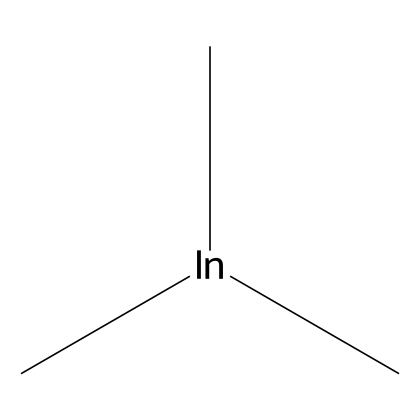What is the central metal atom in trimethylindium? The SMILES representation indicates the presence of 'In', which stands for indium, as the central metal atom in the compound.
Answer: indium How many carbon atoms are present in trimethylindium? The SMILES structure shows three 'C' atoms, meaning there are three carbon atoms in the compound.
Answer: three What type of bonding characterizes the carbon-indium structure in trimethylindium? The presence of carbon bonded to indium suggests covalent bonding, as organometallic compounds typically exhibit covalent connections between metals and organic groups.
Answer: covalent What is the formula for trimethylindium? By interpreting the SMILES code, we can count components: there are three methyl groups (each represented by 'C') and one indium ('In'); thus the formula is C3H9In, noting implicit hydrogen atoms in the methyl groups.
Answer: C3H9In What organometallic property does trimethylindium exhibit due to its structure? The presence of indium bonded to organic methyl groups indicates that trimethylindium is a precursor in semiconductor fabrication, exhibiting properties suited for thin film deposition in electronics.
Answer: semiconductor precursor Why is trimethylindium considered an organometallic compound? This compound contains both carbon (from the methyl groups) and a metal (indium), which fits the definition of organometallic compounds being composed of metal-carbon bonds, typical of organometallic chemistry.
Answer: metal-carbon bond 